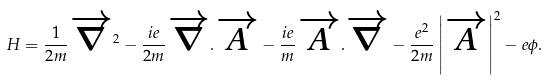Convert formula to latex. <formula><loc_0><loc_0><loc_500><loc_500>H = \frac { 1 } { 2 m } \overrightarrow { \nabla } ^ { 2 } - \frac { i e } { 2 m } \overrightarrow { \nabla } . \overrightarrow { A } - \frac { i e } { m } \overrightarrow { A } . \overrightarrow { \nabla } - \frac { e ^ { 2 } } { 2 m } \left | \overrightarrow { A } \right | ^ { 2 } - e \phi .</formula> 